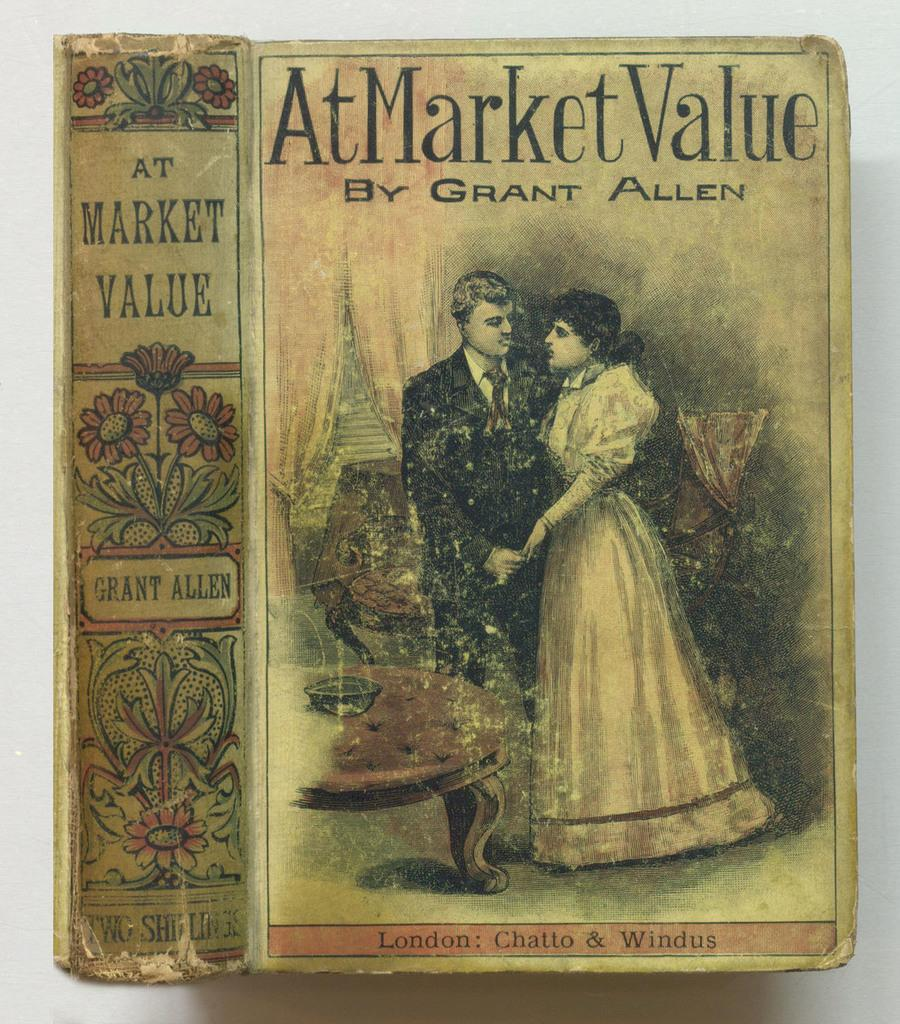<image>
Write a terse but informative summary of the picture. A faded book called At Market Value by Grant Allen has a couple on the cover. 